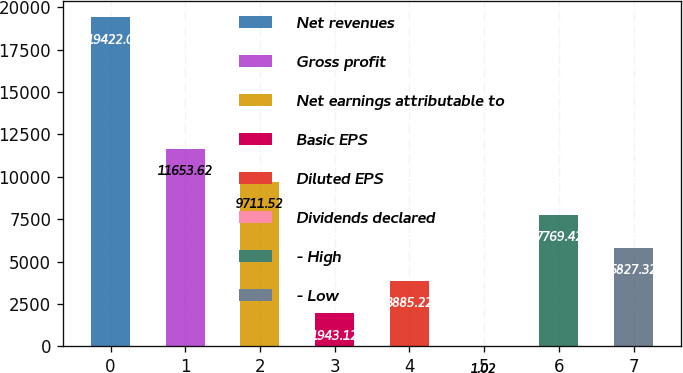Convert chart to OTSL. <chart><loc_0><loc_0><loc_500><loc_500><bar_chart><fcel>Net revenues<fcel>Gross profit<fcel>Net earnings attributable to<fcel>Basic EPS<fcel>Diluted EPS<fcel>Dividends declared<fcel>- High<fcel>- Low<nl><fcel>19422<fcel>11653.6<fcel>9711.52<fcel>1943.12<fcel>3885.22<fcel>1.02<fcel>7769.42<fcel>5827.32<nl></chart> 